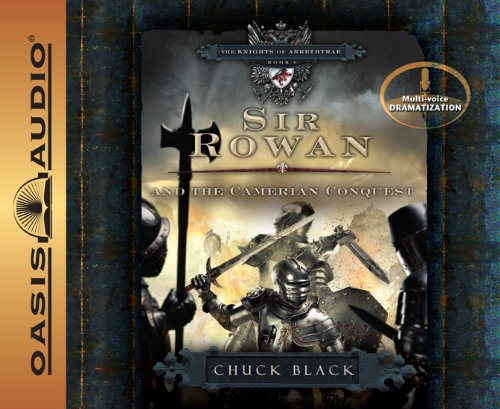What is the main theme explored in Sir Rowan and the Camerian Conquest? The book primarily explores themes of bravery, heroism, and moral integrity as Sir Rowan undertakes a quest that tests his virtues against various adversities. 